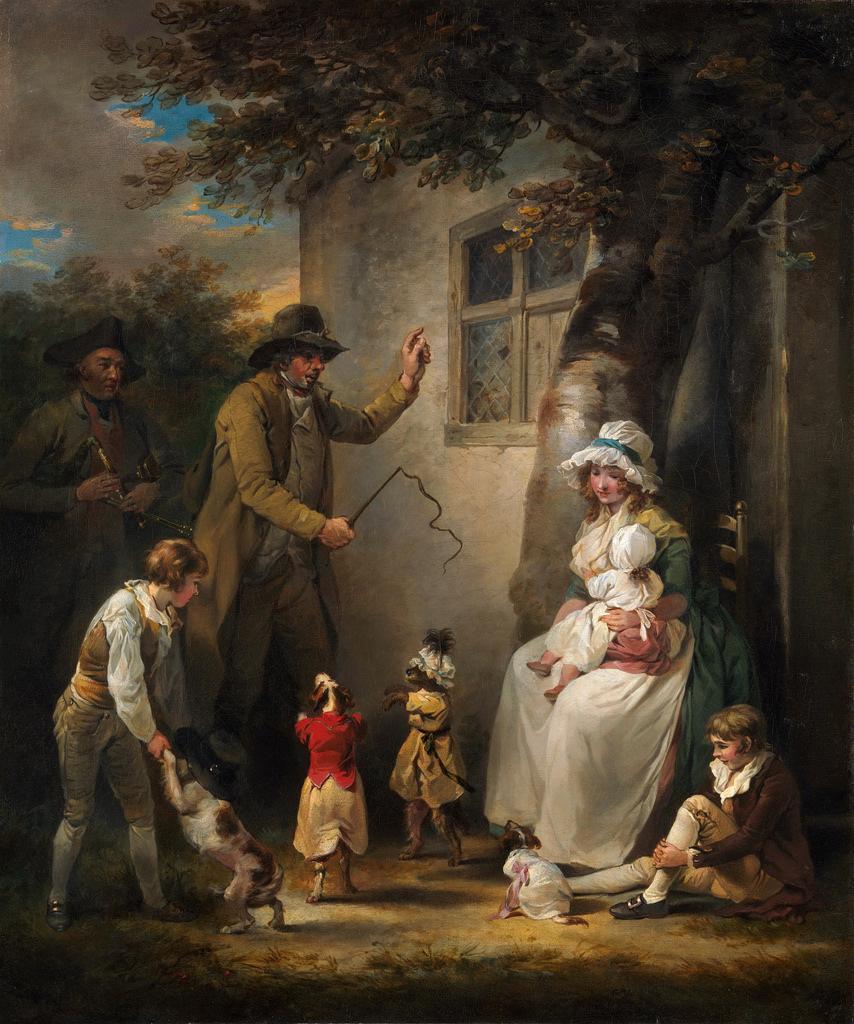How would you summarize this image in a sentence or two? In this picture I can see the painting. In that painting I can see the woman who is standing near to the trees and house. In front of the window there is a man who is holding a hunter. Besides him I can see the children. On the left there is a girl who is holding a dog's hand. 